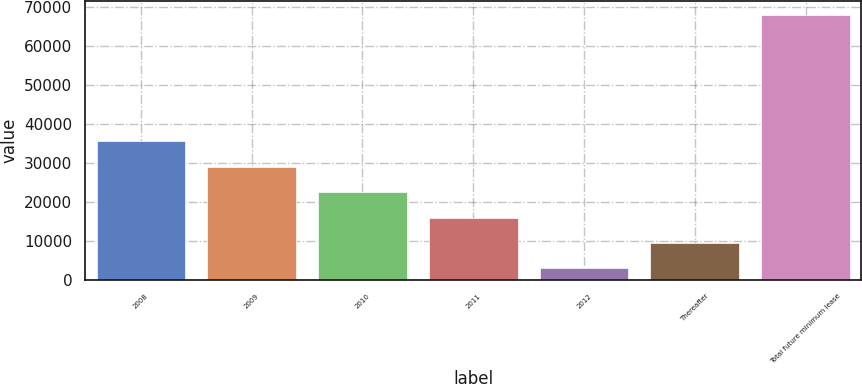Convert chart to OTSL. <chart><loc_0><loc_0><loc_500><loc_500><bar_chart><fcel>2008<fcel>2009<fcel>2010<fcel>2011<fcel>2012<fcel>Thereafter<fcel>Total future minimum lease<nl><fcel>35503.5<fcel>28988<fcel>22472.5<fcel>15957<fcel>2926<fcel>9441.5<fcel>68081<nl></chart> 